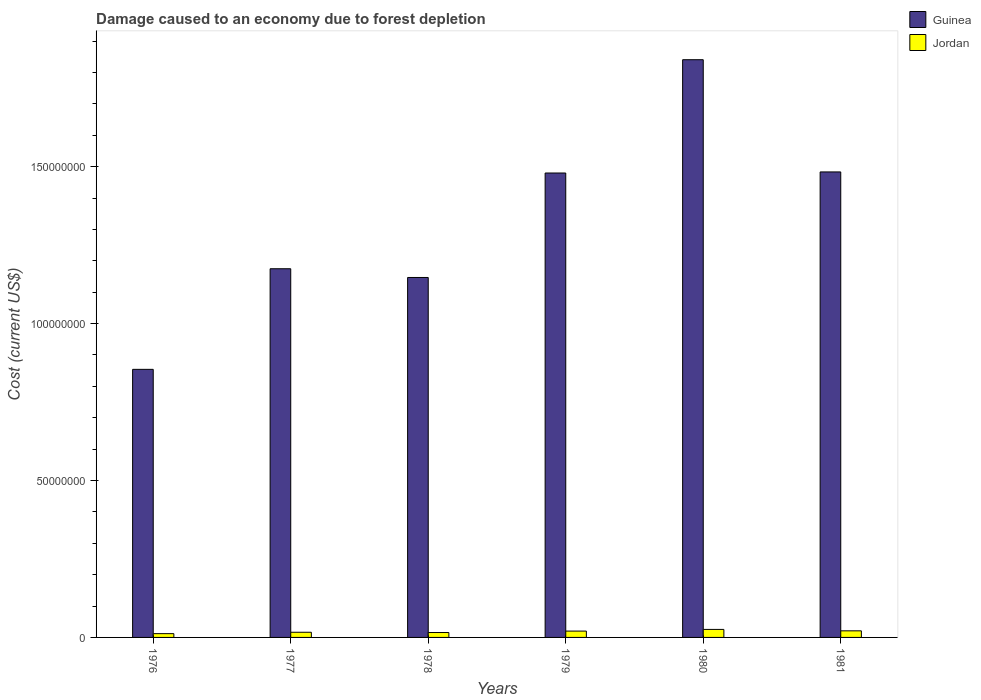How many groups of bars are there?
Offer a very short reply. 6. Are the number of bars per tick equal to the number of legend labels?
Your answer should be compact. Yes. Are the number of bars on each tick of the X-axis equal?
Keep it short and to the point. Yes. How many bars are there on the 5th tick from the left?
Provide a short and direct response. 2. How many bars are there on the 1st tick from the right?
Ensure brevity in your answer.  2. What is the cost of damage caused due to forest depletion in Guinea in 1978?
Your answer should be very brief. 1.15e+08. Across all years, what is the maximum cost of damage caused due to forest depletion in Guinea?
Provide a succinct answer. 1.84e+08. Across all years, what is the minimum cost of damage caused due to forest depletion in Jordan?
Ensure brevity in your answer.  1.20e+06. In which year was the cost of damage caused due to forest depletion in Jordan maximum?
Your response must be concise. 1980. In which year was the cost of damage caused due to forest depletion in Jordan minimum?
Your answer should be very brief. 1976. What is the total cost of damage caused due to forest depletion in Jordan in the graph?
Ensure brevity in your answer.  1.11e+07. What is the difference between the cost of damage caused due to forest depletion in Guinea in 1976 and that in 1981?
Keep it short and to the point. -6.29e+07. What is the difference between the cost of damage caused due to forest depletion in Jordan in 1976 and the cost of damage caused due to forest depletion in Guinea in 1979?
Provide a succinct answer. -1.47e+08. What is the average cost of damage caused due to forest depletion in Jordan per year?
Offer a terse response. 1.85e+06. In the year 1981, what is the difference between the cost of damage caused due to forest depletion in Guinea and cost of damage caused due to forest depletion in Jordan?
Give a very brief answer. 1.46e+08. What is the ratio of the cost of damage caused due to forest depletion in Jordan in 1976 to that in 1977?
Provide a succinct answer. 0.73. What is the difference between the highest and the second highest cost of damage caused due to forest depletion in Guinea?
Give a very brief answer. 3.58e+07. What is the difference between the highest and the lowest cost of damage caused due to forest depletion in Guinea?
Provide a succinct answer. 9.87e+07. In how many years, is the cost of damage caused due to forest depletion in Guinea greater than the average cost of damage caused due to forest depletion in Guinea taken over all years?
Offer a terse response. 3. Is the sum of the cost of damage caused due to forest depletion in Jordan in 1979 and 1980 greater than the maximum cost of damage caused due to forest depletion in Guinea across all years?
Offer a very short reply. No. What does the 1st bar from the left in 1976 represents?
Offer a terse response. Guinea. What does the 1st bar from the right in 1976 represents?
Your response must be concise. Jordan. How many bars are there?
Your answer should be very brief. 12. Are all the bars in the graph horizontal?
Provide a short and direct response. No. What is the difference between two consecutive major ticks on the Y-axis?
Your response must be concise. 5.00e+07. Does the graph contain grids?
Offer a very short reply. No. Where does the legend appear in the graph?
Provide a short and direct response. Top right. What is the title of the graph?
Provide a succinct answer. Damage caused to an economy due to forest depletion. Does "Portugal" appear as one of the legend labels in the graph?
Offer a terse response. No. What is the label or title of the X-axis?
Your answer should be compact. Years. What is the label or title of the Y-axis?
Offer a very short reply. Cost (current US$). What is the Cost (current US$) of Guinea in 1976?
Your response must be concise. 8.54e+07. What is the Cost (current US$) of Jordan in 1976?
Give a very brief answer. 1.20e+06. What is the Cost (current US$) of Guinea in 1977?
Ensure brevity in your answer.  1.17e+08. What is the Cost (current US$) in Jordan in 1977?
Your response must be concise. 1.65e+06. What is the Cost (current US$) of Guinea in 1978?
Your response must be concise. 1.15e+08. What is the Cost (current US$) of Jordan in 1978?
Give a very brief answer. 1.56e+06. What is the Cost (current US$) in Guinea in 1979?
Provide a short and direct response. 1.48e+08. What is the Cost (current US$) in Jordan in 1979?
Provide a short and direct response. 2.02e+06. What is the Cost (current US$) of Guinea in 1980?
Make the answer very short. 1.84e+08. What is the Cost (current US$) in Jordan in 1980?
Your answer should be compact. 2.55e+06. What is the Cost (current US$) in Guinea in 1981?
Offer a very short reply. 1.48e+08. What is the Cost (current US$) of Jordan in 1981?
Ensure brevity in your answer.  2.10e+06. Across all years, what is the maximum Cost (current US$) of Guinea?
Your answer should be very brief. 1.84e+08. Across all years, what is the maximum Cost (current US$) in Jordan?
Keep it short and to the point. 2.55e+06. Across all years, what is the minimum Cost (current US$) in Guinea?
Keep it short and to the point. 8.54e+07. Across all years, what is the minimum Cost (current US$) in Jordan?
Keep it short and to the point. 1.20e+06. What is the total Cost (current US$) in Guinea in the graph?
Your answer should be very brief. 7.98e+08. What is the total Cost (current US$) of Jordan in the graph?
Your answer should be compact. 1.11e+07. What is the difference between the Cost (current US$) in Guinea in 1976 and that in 1977?
Your answer should be very brief. -3.21e+07. What is the difference between the Cost (current US$) of Jordan in 1976 and that in 1977?
Your answer should be compact. -4.44e+05. What is the difference between the Cost (current US$) in Guinea in 1976 and that in 1978?
Your response must be concise. -2.93e+07. What is the difference between the Cost (current US$) in Jordan in 1976 and that in 1978?
Make the answer very short. -3.60e+05. What is the difference between the Cost (current US$) in Guinea in 1976 and that in 1979?
Your response must be concise. -6.26e+07. What is the difference between the Cost (current US$) in Jordan in 1976 and that in 1979?
Your answer should be very brief. -8.18e+05. What is the difference between the Cost (current US$) of Guinea in 1976 and that in 1980?
Provide a succinct answer. -9.87e+07. What is the difference between the Cost (current US$) of Jordan in 1976 and that in 1980?
Your answer should be compact. -1.35e+06. What is the difference between the Cost (current US$) of Guinea in 1976 and that in 1981?
Provide a short and direct response. -6.29e+07. What is the difference between the Cost (current US$) of Jordan in 1976 and that in 1981?
Keep it short and to the point. -8.97e+05. What is the difference between the Cost (current US$) in Guinea in 1977 and that in 1978?
Provide a succinct answer. 2.78e+06. What is the difference between the Cost (current US$) of Jordan in 1977 and that in 1978?
Offer a terse response. 8.35e+04. What is the difference between the Cost (current US$) in Guinea in 1977 and that in 1979?
Provide a short and direct response. -3.05e+07. What is the difference between the Cost (current US$) in Jordan in 1977 and that in 1979?
Offer a terse response. -3.74e+05. What is the difference between the Cost (current US$) of Guinea in 1977 and that in 1980?
Keep it short and to the point. -6.66e+07. What is the difference between the Cost (current US$) in Jordan in 1977 and that in 1980?
Offer a very short reply. -9.07e+05. What is the difference between the Cost (current US$) of Guinea in 1977 and that in 1981?
Your answer should be compact. -3.09e+07. What is the difference between the Cost (current US$) in Jordan in 1977 and that in 1981?
Provide a short and direct response. -4.53e+05. What is the difference between the Cost (current US$) of Guinea in 1978 and that in 1979?
Keep it short and to the point. -3.33e+07. What is the difference between the Cost (current US$) in Jordan in 1978 and that in 1979?
Offer a terse response. -4.58e+05. What is the difference between the Cost (current US$) in Guinea in 1978 and that in 1980?
Your answer should be compact. -6.94e+07. What is the difference between the Cost (current US$) in Jordan in 1978 and that in 1980?
Make the answer very short. -9.91e+05. What is the difference between the Cost (current US$) in Guinea in 1978 and that in 1981?
Make the answer very short. -3.36e+07. What is the difference between the Cost (current US$) in Jordan in 1978 and that in 1981?
Give a very brief answer. -5.37e+05. What is the difference between the Cost (current US$) of Guinea in 1979 and that in 1980?
Your answer should be very brief. -3.61e+07. What is the difference between the Cost (current US$) in Jordan in 1979 and that in 1980?
Offer a terse response. -5.33e+05. What is the difference between the Cost (current US$) of Guinea in 1979 and that in 1981?
Your answer should be very brief. -3.43e+05. What is the difference between the Cost (current US$) in Jordan in 1979 and that in 1981?
Offer a terse response. -7.91e+04. What is the difference between the Cost (current US$) in Guinea in 1980 and that in 1981?
Give a very brief answer. 3.58e+07. What is the difference between the Cost (current US$) of Jordan in 1980 and that in 1981?
Your answer should be very brief. 4.54e+05. What is the difference between the Cost (current US$) of Guinea in 1976 and the Cost (current US$) of Jordan in 1977?
Ensure brevity in your answer.  8.38e+07. What is the difference between the Cost (current US$) in Guinea in 1976 and the Cost (current US$) in Jordan in 1978?
Provide a short and direct response. 8.39e+07. What is the difference between the Cost (current US$) in Guinea in 1976 and the Cost (current US$) in Jordan in 1979?
Your response must be concise. 8.34e+07. What is the difference between the Cost (current US$) of Guinea in 1976 and the Cost (current US$) of Jordan in 1980?
Your response must be concise. 8.29e+07. What is the difference between the Cost (current US$) in Guinea in 1976 and the Cost (current US$) in Jordan in 1981?
Make the answer very short. 8.33e+07. What is the difference between the Cost (current US$) in Guinea in 1977 and the Cost (current US$) in Jordan in 1978?
Offer a very short reply. 1.16e+08. What is the difference between the Cost (current US$) in Guinea in 1977 and the Cost (current US$) in Jordan in 1979?
Offer a terse response. 1.15e+08. What is the difference between the Cost (current US$) in Guinea in 1977 and the Cost (current US$) in Jordan in 1980?
Ensure brevity in your answer.  1.15e+08. What is the difference between the Cost (current US$) of Guinea in 1977 and the Cost (current US$) of Jordan in 1981?
Your answer should be compact. 1.15e+08. What is the difference between the Cost (current US$) in Guinea in 1978 and the Cost (current US$) in Jordan in 1979?
Make the answer very short. 1.13e+08. What is the difference between the Cost (current US$) of Guinea in 1978 and the Cost (current US$) of Jordan in 1980?
Your answer should be very brief. 1.12e+08. What is the difference between the Cost (current US$) in Guinea in 1978 and the Cost (current US$) in Jordan in 1981?
Keep it short and to the point. 1.13e+08. What is the difference between the Cost (current US$) of Guinea in 1979 and the Cost (current US$) of Jordan in 1980?
Keep it short and to the point. 1.45e+08. What is the difference between the Cost (current US$) of Guinea in 1979 and the Cost (current US$) of Jordan in 1981?
Provide a succinct answer. 1.46e+08. What is the difference between the Cost (current US$) of Guinea in 1980 and the Cost (current US$) of Jordan in 1981?
Your response must be concise. 1.82e+08. What is the average Cost (current US$) of Guinea per year?
Give a very brief answer. 1.33e+08. What is the average Cost (current US$) of Jordan per year?
Give a very brief answer. 1.85e+06. In the year 1976, what is the difference between the Cost (current US$) in Guinea and Cost (current US$) in Jordan?
Ensure brevity in your answer.  8.42e+07. In the year 1977, what is the difference between the Cost (current US$) in Guinea and Cost (current US$) in Jordan?
Your answer should be compact. 1.16e+08. In the year 1978, what is the difference between the Cost (current US$) of Guinea and Cost (current US$) of Jordan?
Your answer should be compact. 1.13e+08. In the year 1979, what is the difference between the Cost (current US$) in Guinea and Cost (current US$) in Jordan?
Keep it short and to the point. 1.46e+08. In the year 1980, what is the difference between the Cost (current US$) in Guinea and Cost (current US$) in Jordan?
Provide a succinct answer. 1.82e+08. In the year 1981, what is the difference between the Cost (current US$) of Guinea and Cost (current US$) of Jordan?
Provide a succinct answer. 1.46e+08. What is the ratio of the Cost (current US$) of Guinea in 1976 to that in 1977?
Offer a terse response. 0.73. What is the ratio of the Cost (current US$) in Jordan in 1976 to that in 1977?
Your response must be concise. 0.73. What is the ratio of the Cost (current US$) in Guinea in 1976 to that in 1978?
Make the answer very short. 0.74. What is the ratio of the Cost (current US$) of Jordan in 1976 to that in 1978?
Keep it short and to the point. 0.77. What is the ratio of the Cost (current US$) in Guinea in 1976 to that in 1979?
Offer a very short reply. 0.58. What is the ratio of the Cost (current US$) of Jordan in 1976 to that in 1979?
Offer a terse response. 0.6. What is the ratio of the Cost (current US$) in Guinea in 1976 to that in 1980?
Provide a short and direct response. 0.46. What is the ratio of the Cost (current US$) in Jordan in 1976 to that in 1980?
Ensure brevity in your answer.  0.47. What is the ratio of the Cost (current US$) of Guinea in 1976 to that in 1981?
Offer a terse response. 0.58. What is the ratio of the Cost (current US$) of Jordan in 1976 to that in 1981?
Your answer should be compact. 0.57. What is the ratio of the Cost (current US$) in Guinea in 1977 to that in 1978?
Give a very brief answer. 1.02. What is the ratio of the Cost (current US$) in Jordan in 1977 to that in 1978?
Offer a terse response. 1.05. What is the ratio of the Cost (current US$) in Guinea in 1977 to that in 1979?
Ensure brevity in your answer.  0.79. What is the ratio of the Cost (current US$) in Jordan in 1977 to that in 1979?
Keep it short and to the point. 0.81. What is the ratio of the Cost (current US$) of Guinea in 1977 to that in 1980?
Keep it short and to the point. 0.64. What is the ratio of the Cost (current US$) of Jordan in 1977 to that in 1980?
Offer a very short reply. 0.64. What is the ratio of the Cost (current US$) of Guinea in 1977 to that in 1981?
Give a very brief answer. 0.79. What is the ratio of the Cost (current US$) of Jordan in 1977 to that in 1981?
Offer a very short reply. 0.78. What is the ratio of the Cost (current US$) in Guinea in 1978 to that in 1979?
Your response must be concise. 0.78. What is the ratio of the Cost (current US$) of Jordan in 1978 to that in 1979?
Your response must be concise. 0.77. What is the ratio of the Cost (current US$) of Guinea in 1978 to that in 1980?
Offer a very short reply. 0.62. What is the ratio of the Cost (current US$) of Jordan in 1978 to that in 1980?
Provide a succinct answer. 0.61. What is the ratio of the Cost (current US$) in Guinea in 1978 to that in 1981?
Keep it short and to the point. 0.77. What is the ratio of the Cost (current US$) of Jordan in 1978 to that in 1981?
Keep it short and to the point. 0.74. What is the ratio of the Cost (current US$) of Guinea in 1979 to that in 1980?
Your answer should be compact. 0.8. What is the ratio of the Cost (current US$) of Jordan in 1979 to that in 1980?
Your response must be concise. 0.79. What is the ratio of the Cost (current US$) in Guinea in 1979 to that in 1981?
Your answer should be very brief. 1. What is the ratio of the Cost (current US$) of Jordan in 1979 to that in 1981?
Your answer should be very brief. 0.96. What is the ratio of the Cost (current US$) of Guinea in 1980 to that in 1981?
Your response must be concise. 1.24. What is the ratio of the Cost (current US$) of Jordan in 1980 to that in 1981?
Ensure brevity in your answer.  1.22. What is the difference between the highest and the second highest Cost (current US$) of Guinea?
Give a very brief answer. 3.58e+07. What is the difference between the highest and the second highest Cost (current US$) of Jordan?
Ensure brevity in your answer.  4.54e+05. What is the difference between the highest and the lowest Cost (current US$) in Guinea?
Your answer should be very brief. 9.87e+07. What is the difference between the highest and the lowest Cost (current US$) of Jordan?
Offer a very short reply. 1.35e+06. 